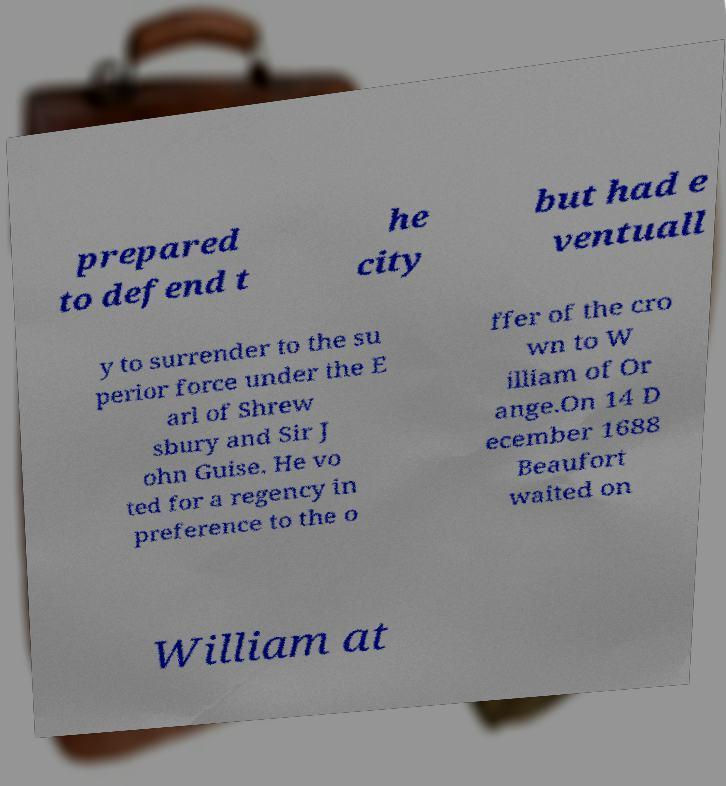Please read and relay the text visible in this image. What does it say? prepared to defend t he city but had e ventuall y to surrender to the su perior force under the E arl of Shrew sbury and Sir J ohn Guise. He vo ted for a regency in preference to the o ffer of the cro wn to W illiam of Or ange.On 14 D ecember 1688 Beaufort waited on William at 